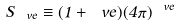<formula> <loc_0><loc_0><loc_500><loc_500>S _ { \ v e } \equiv \Gamma ( 1 + \ v e ) ( 4 \pi ) ^ { \ v e }</formula> 